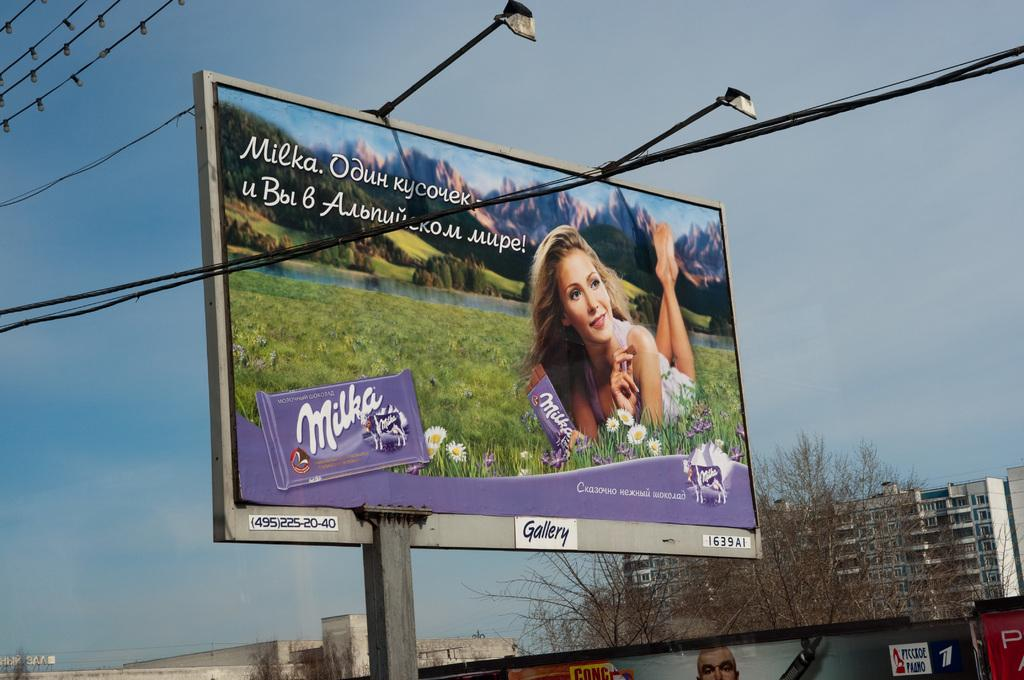<image>
Render a clear and concise summary of the photo. A beautiful women is lying on the grass for a billboard by Milka 